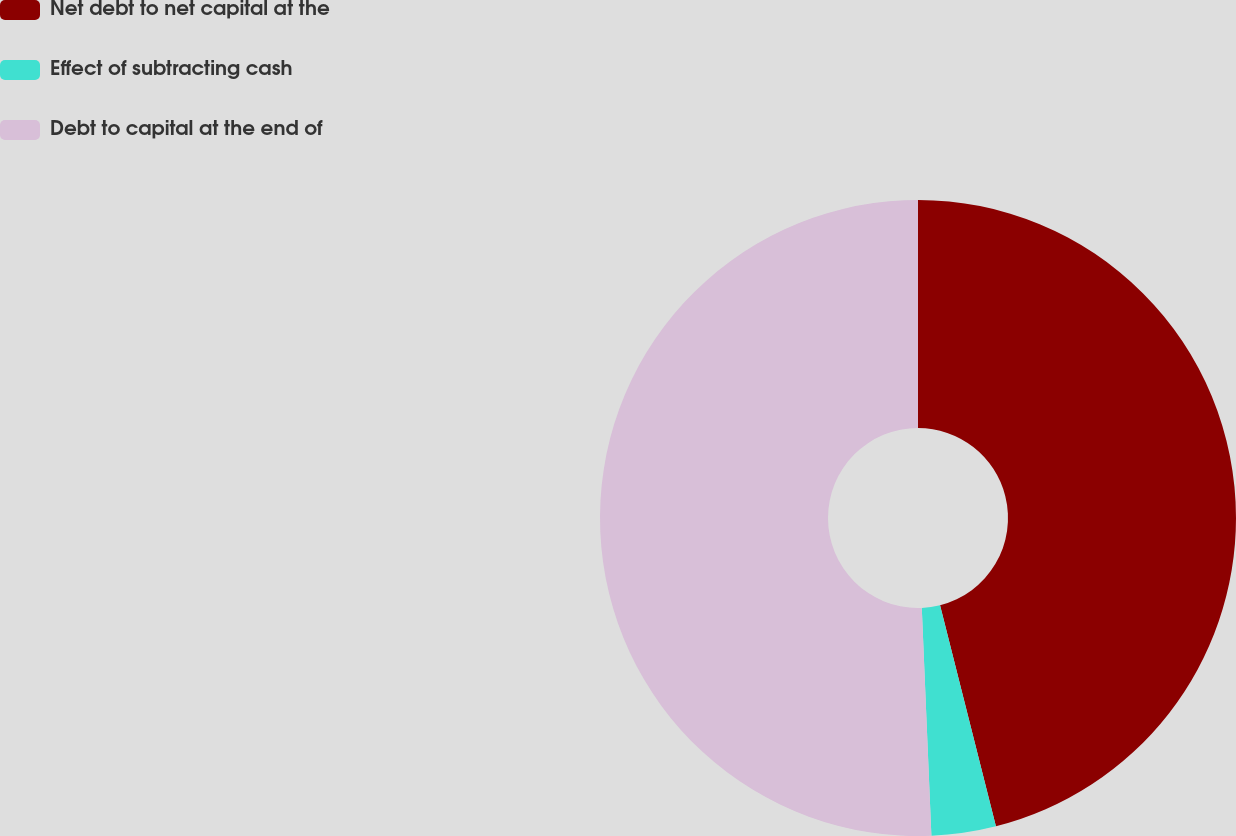Convert chart. <chart><loc_0><loc_0><loc_500><loc_500><pie_chart><fcel>Net debt to net capital at the<fcel>Effect of subtracting cash<fcel>Debt to capital at the end of<nl><fcel>46.06%<fcel>3.27%<fcel>50.67%<nl></chart> 